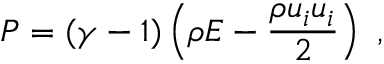<formula> <loc_0><loc_0><loc_500><loc_500>P = ( \gamma - 1 ) \left ( \rho E - \frac { \rho u _ { i } u _ { i } } { 2 } \right ) ,</formula> 